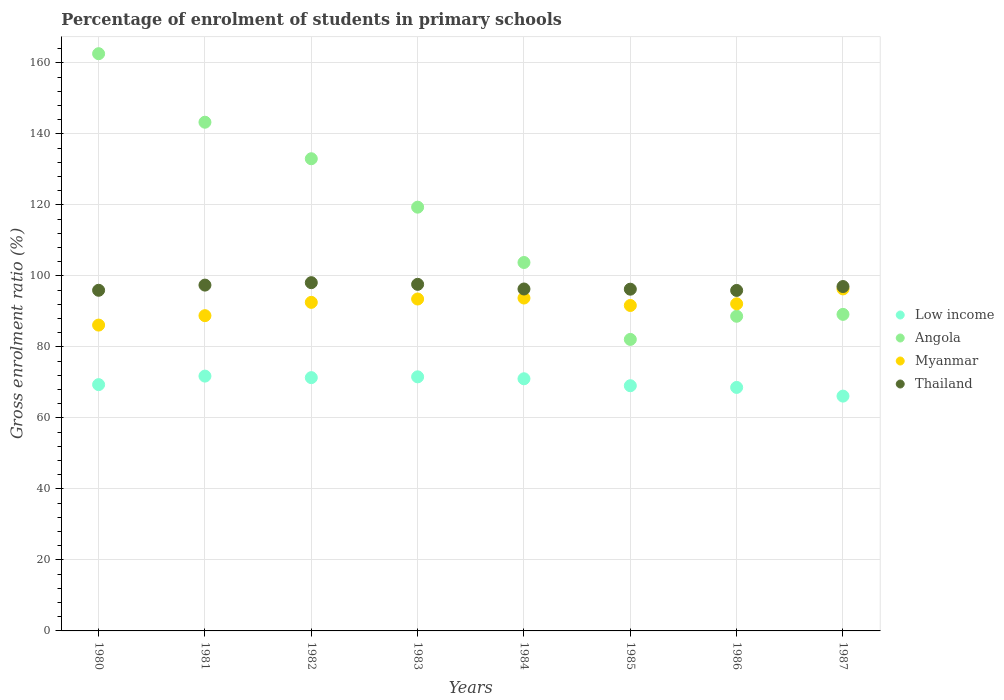What is the percentage of students enrolled in primary schools in Thailand in 1986?
Make the answer very short. 95.92. Across all years, what is the maximum percentage of students enrolled in primary schools in Angola?
Provide a short and direct response. 162.62. Across all years, what is the minimum percentage of students enrolled in primary schools in Myanmar?
Offer a terse response. 86.16. In which year was the percentage of students enrolled in primary schools in Angola maximum?
Your response must be concise. 1980. In which year was the percentage of students enrolled in primary schools in Myanmar minimum?
Give a very brief answer. 1980. What is the total percentage of students enrolled in primary schools in Thailand in the graph?
Offer a very short reply. 774.68. What is the difference between the percentage of students enrolled in primary schools in Angola in 1986 and that in 1987?
Provide a succinct answer. -0.53. What is the difference between the percentage of students enrolled in primary schools in Angola in 1984 and the percentage of students enrolled in primary schools in Low income in 1983?
Provide a short and direct response. 32.21. What is the average percentage of students enrolled in primary schools in Thailand per year?
Keep it short and to the point. 96.84. In the year 1984, what is the difference between the percentage of students enrolled in primary schools in Thailand and percentage of students enrolled in primary schools in Myanmar?
Make the answer very short. 2.54. What is the ratio of the percentage of students enrolled in primary schools in Myanmar in 1983 to that in 1984?
Offer a very short reply. 1. Is the percentage of students enrolled in primary schools in Low income in 1981 less than that in 1986?
Your answer should be very brief. No. What is the difference between the highest and the second highest percentage of students enrolled in primary schools in Angola?
Provide a short and direct response. 19.3. What is the difference between the highest and the lowest percentage of students enrolled in primary schools in Low income?
Ensure brevity in your answer.  5.64. Does the percentage of students enrolled in primary schools in Low income monotonically increase over the years?
Keep it short and to the point. No. Is the percentage of students enrolled in primary schools in Myanmar strictly greater than the percentage of students enrolled in primary schools in Angola over the years?
Provide a succinct answer. No. Is the percentage of students enrolled in primary schools in Thailand strictly less than the percentage of students enrolled in primary schools in Low income over the years?
Your response must be concise. No. How many years are there in the graph?
Offer a very short reply. 8. What is the difference between two consecutive major ticks on the Y-axis?
Offer a very short reply. 20. How are the legend labels stacked?
Make the answer very short. Vertical. What is the title of the graph?
Keep it short and to the point. Percentage of enrolment of students in primary schools. What is the Gross enrolment ratio (%) of Low income in 1980?
Provide a short and direct response. 69.39. What is the Gross enrolment ratio (%) in Angola in 1980?
Make the answer very short. 162.62. What is the Gross enrolment ratio (%) in Myanmar in 1980?
Offer a very short reply. 86.16. What is the Gross enrolment ratio (%) in Thailand in 1980?
Your answer should be very brief. 95.97. What is the Gross enrolment ratio (%) of Low income in 1981?
Your response must be concise. 71.79. What is the Gross enrolment ratio (%) in Angola in 1981?
Keep it short and to the point. 143.31. What is the Gross enrolment ratio (%) in Myanmar in 1981?
Keep it short and to the point. 88.82. What is the Gross enrolment ratio (%) of Thailand in 1981?
Make the answer very short. 97.42. What is the Gross enrolment ratio (%) in Low income in 1982?
Provide a succinct answer. 71.36. What is the Gross enrolment ratio (%) in Angola in 1982?
Make the answer very short. 133.02. What is the Gross enrolment ratio (%) in Myanmar in 1982?
Make the answer very short. 92.56. What is the Gross enrolment ratio (%) in Thailand in 1982?
Ensure brevity in your answer.  98.11. What is the Gross enrolment ratio (%) in Low income in 1983?
Your answer should be very brief. 71.58. What is the Gross enrolment ratio (%) of Angola in 1983?
Your answer should be very brief. 119.38. What is the Gross enrolment ratio (%) of Myanmar in 1983?
Your answer should be compact. 93.51. What is the Gross enrolment ratio (%) in Thailand in 1983?
Make the answer very short. 97.64. What is the Gross enrolment ratio (%) in Low income in 1984?
Provide a short and direct response. 71.04. What is the Gross enrolment ratio (%) in Angola in 1984?
Your answer should be compact. 103.79. What is the Gross enrolment ratio (%) of Myanmar in 1984?
Give a very brief answer. 93.79. What is the Gross enrolment ratio (%) of Thailand in 1984?
Ensure brevity in your answer.  96.33. What is the Gross enrolment ratio (%) in Low income in 1985?
Offer a terse response. 69.08. What is the Gross enrolment ratio (%) in Angola in 1985?
Provide a succinct answer. 82.12. What is the Gross enrolment ratio (%) of Myanmar in 1985?
Provide a short and direct response. 91.68. What is the Gross enrolment ratio (%) of Thailand in 1985?
Ensure brevity in your answer.  96.27. What is the Gross enrolment ratio (%) of Low income in 1986?
Your response must be concise. 68.6. What is the Gross enrolment ratio (%) in Angola in 1986?
Keep it short and to the point. 88.65. What is the Gross enrolment ratio (%) of Myanmar in 1986?
Make the answer very short. 92.15. What is the Gross enrolment ratio (%) of Thailand in 1986?
Ensure brevity in your answer.  95.92. What is the Gross enrolment ratio (%) of Low income in 1987?
Provide a short and direct response. 66.15. What is the Gross enrolment ratio (%) in Angola in 1987?
Your answer should be compact. 89.18. What is the Gross enrolment ratio (%) of Myanmar in 1987?
Your answer should be very brief. 96.35. What is the Gross enrolment ratio (%) of Thailand in 1987?
Your answer should be very brief. 97.02. Across all years, what is the maximum Gross enrolment ratio (%) in Low income?
Your answer should be very brief. 71.79. Across all years, what is the maximum Gross enrolment ratio (%) in Angola?
Ensure brevity in your answer.  162.62. Across all years, what is the maximum Gross enrolment ratio (%) of Myanmar?
Your answer should be compact. 96.35. Across all years, what is the maximum Gross enrolment ratio (%) in Thailand?
Keep it short and to the point. 98.11. Across all years, what is the minimum Gross enrolment ratio (%) in Low income?
Give a very brief answer. 66.15. Across all years, what is the minimum Gross enrolment ratio (%) of Angola?
Your answer should be compact. 82.12. Across all years, what is the minimum Gross enrolment ratio (%) in Myanmar?
Your answer should be compact. 86.16. Across all years, what is the minimum Gross enrolment ratio (%) of Thailand?
Ensure brevity in your answer.  95.92. What is the total Gross enrolment ratio (%) in Low income in the graph?
Offer a terse response. 558.97. What is the total Gross enrolment ratio (%) of Angola in the graph?
Make the answer very short. 922.07. What is the total Gross enrolment ratio (%) in Myanmar in the graph?
Your answer should be compact. 735.02. What is the total Gross enrolment ratio (%) of Thailand in the graph?
Your response must be concise. 774.68. What is the difference between the Gross enrolment ratio (%) in Low income in 1980 and that in 1981?
Keep it short and to the point. -2.4. What is the difference between the Gross enrolment ratio (%) in Angola in 1980 and that in 1981?
Make the answer very short. 19.3. What is the difference between the Gross enrolment ratio (%) of Myanmar in 1980 and that in 1981?
Provide a short and direct response. -2.66. What is the difference between the Gross enrolment ratio (%) of Thailand in 1980 and that in 1981?
Offer a terse response. -1.46. What is the difference between the Gross enrolment ratio (%) of Low income in 1980 and that in 1982?
Provide a succinct answer. -1.97. What is the difference between the Gross enrolment ratio (%) of Angola in 1980 and that in 1982?
Keep it short and to the point. 29.59. What is the difference between the Gross enrolment ratio (%) of Myanmar in 1980 and that in 1982?
Keep it short and to the point. -6.4. What is the difference between the Gross enrolment ratio (%) of Thailand in 1980 and that in 1982?
Ensure brevity in your answer.  -2.15. What is the difference between the Gross enrolment ratio (%) of Low income in 1980 and that in 1983?
Your answer should be compact. -2.2. What is the difference between the Gross enrolment ratio (%) in Angola in 1980 and that in 1983?
Offer a very short reply. 43.24. What is the difference between the Gross enrolment ratio (%) in Myanmar in 1980 and that in 1983?
Make the answer very short. -7.35. What is the difference between the Gross enrolment ratio (%) in Thailand in 1980 and that in 1983?
Offer a terse response. -1.67. What is the difference between the Gross enrolment ratio (%) of Low income in 1980 and that in 1984?
Your answer should be very brief. -1.65. What is the difference between the Gross enrolment ratio (%) of Angola in 1980 and that in 1984?
Ensure brevity in your answer.  58.82. What is the difference between the Gross enrolment ratio (%) of Myanmar in 1980 and that in 1984?
Keep it short and to the point. -7.63. What is the difference between the Gross enrolment ratio (%) of Thailand in 1980 and that in 1984?
Give a very brief answer. -0.36. What is the difference between the Gross enrolment ratio (%) in Low income in 1980 and that in 1985?
Make the answer very short. 0.31. What is the difference between the Gross enrolment ratio (%) of Angola in 1980 and that in 1985?
Provide a short and direct response. 80.49. What is the difference between the Gross enrolment ratio (%) in Myanmar in 1980 and that in 1985?
Make the answer very short. -5.52. What is the difference between the Gross enrolment ratio (%) in Thailand in 1980 and that in 1985?
Provide a succinct answer. -0.31. What is the difference between the Gross enrolment ratio (%) of Low income in 1980 and that in 1986?
Offer a very short reply. 0.79. What is the difference between the Gross enrolment ratio (%) of Angola in 1980 and that in 1986?
Your answer should be compact. 73.97. What is the difference between the Gross enrolment ratio (%) of Myanmar in 1980 and that in 1986?
Your response must be concise. -5.99. What is the difference between the Gross enrolment ratio (%) of Thailand in 1980 and that in 1986?
Your answer should be very brief. 0.04. What is the difference between the Gross enrolment ratio (%) of Low income in 1980 and that in 1987?
Offer a terse response. 3.23. What is the difference between the Gross enrolment ratio (%) in Angola in 1980 and that in 1987?
Ensure brevity in your answer.  73.44. What is the difference between the Gross enrolment ratio (%) of Myanmar in 1980 and that in 1987?
Keep it short and to the point. -10.19. What is the difference between the Gross enrolment ratio (%) of Thailand in 1980 and that in 1987?
Keep it short and to the point. -1.05. What is the difference between the Gross enrolment ratio (%) in Low income in 1981 and that in 1982?
Your answer should be very brief. 0.43. What is the difference between the Gross enrolment ratio (%) of Angola in 1981 and that in 1982?
Offer a terse response. 10.29. What is the difference between the Gross enrolment ratio (%) in Myanmar in 1981 and that in 1982?
Offer a very short reply. -3.74. What is the difference between the Gross enrolment ratio (%) in Thailand in 1981 and that in 1982?
Make the answer very short. -0.69. What is the difference between the Gross enrolment ratio (%) in Low income in 1981 and that in 1983?
Your answer should be very brief. 0.21. What is the difference between the Gross enrolment ratio (%) of Angola in 1981 and that in 1983?
Keep it short and to the point. 23.93. What is the difference between the Gross enrolment ratio (%) in Myanmar in 1981 and that in 1983?
Ensure brevity in your answer.  -4.69. What is the difference between the Gross enrolment ratio (%) of Thailand in 1981 and that in 1983?
Provide a succinct answer. -0.22. What is the difference between the Gross enrolment ratio (%) of Low income in 1981 and that in 1984?
Offer a very short reply. 0.75. What is the difference between the Gross enrolment ratio (%) in Angola in 1981 and that in 1984?
Provide a succinct answer. 39.52. What is the difference between the Gross enrolment ratio (%) of Myanmar in 1981 and that in 1984?
Keep it short and to the point. -4.97. What is the difference between the Gross enrolment ratio (%) of Thailand in 1981 and that in 1984?
Keep it short and to the point. 1.1. What is the difference between the Gross enrolment ratio (%) of Low income in 1981 and that in 1985?
Your response must be concise. 2.71. What is the difference between the Gross enrolment ratio (%) of Angola in 1981 and that in 1985?
Your answer should be very brief. 61.19. What is the difference between the Gross enrolment ratio (%) in Myanmar in 1981 and that in 1985?
Provide a short and direct response. -2.87. What is the difference between the Gross enrolment ratio (%) of Thailand in 1981 and that in 1985?
Offer a very short reply. 1.15. What is the difference between the Gross enrolment ratio (%) of Low income in 1981 and that in 1986?
Offer a very short reply. 3.19. What is the difference between the Gross enrolment ratio (%) in Angola in 1981 and that in 1986?
Provide a succinct answer. 54.67. What is the difference between the Gross enrolment ratio (%) of Myanmar in 1981 and that in 1986?
Keep it short and to the point. -3.33. What is the difference between the Gross enrolment ratio (%) in Thailand in 1981 and that in 1986?
Give a very brief answer. 1.5. What is the difference between the Gross enrolment ratio (%) of Low income in 1981 and that in 1987?
Make the answer very short. 5.64. What is the difference between the Gross enrolment ratio (%) in Angola in 1981 and that in 1987?
Your answer should be compact. 54.14. What is the difference between the Gross enrolment ratio (%) of Myanmar in 1981 and that in 1987?
Offer a very short reply. -7.54. What is the difference between the Gross enrolment ratio (%) in Thailand in 1981 and that in 1987?
Your answer should be compact. 0.4. What is the difference between the Gross enrolment ratio (%) in Low income in 1982 and that in 1983?
Your response must be concise. -0.22. What is the difference between the Gross enrolment ratio (%) of Angola in 1982 and that in 1983?
Make the answer very short. 13.64. What is the difference between the Gross enrolment ratio (%) of Myanmar in 1982 and that in 1983?
Keep it short and to the point. -0.94. What is the difference between the Gross enrolment ratio (%) of Thailand in 1982 and that in 1983?
Offer a terse response. 0.47. What is the difference between the Gross enrolment ratio (%) in Low income in 1982 and that in 1984?
Make the answer very short. 0.32. What is the difference between the Gross enrolment ratio (%) of Angola in 1982 and that in 1984?
Give a very brief answer. 29.23. What is the difference between the Gross enrolment ratio (%) of Myanmar in 1982 and that in 1984?
Offer a terse response. -1.22. What is the difference between the Gross enrolment ratio (%) in Thailand in 1982 and that in 1984?
Make the answer very short. 1.78. What is the difference between the Gross enrolment ratio (%) in Low income in 1982 and that in 1985?
Your response must be concise. 2.28. What is the difference between the Gross enrolment ratio (%) of Angola in 1982 and that in 1985?
Ensure brevity in your answer.  50.9. What is the difference between the Gross enrolment ratio (%) of Myanmar in 1982 and that in 1985?
Offer a very short reply. 0.88. What is the difference between the Gross enrolment ratio (%) in Thailand in 1982 and that in 1985?
Offer a very short reply. 1.84. What is the difference between the Gross enrolment ratio (%) in Low income in 1982 and that in 1986?
Ensure brevity in your answer.  2.76. What is the difference between the Gross enrolment ratio (%) in Angola in 1982 and that in 1986?
Give a very brief answer. 44.38. What is the difference between the Gross enrolment ratio (%) of Myanmar in 1982 and that in 1986?
Give a very brief answer. 0.41. What is the difference between the Gross enrolment ratio (%) of Thailand in 1982 and that in 1986?
Make the answer very short. 2.19. What is the difference between the Gross enrolment ratio (%) of Low income in 1982 and that in 1987?
Make the answer very short. 5.21. What is the difference between the Gross enrolment ratio (%) of Angola in 1982 and that in 1987?
Offer a terse response. 43.85. What is the difference between the Gross enrolment ratio (%) in Myanmar in 1982 and that in 1987?
Make the answer very short. -3.79. What is the difference between the Gross enrolment ratio (%) in Thailand in 1982 and that in 1987?
Offer a very short reply. 1.09. What is the difference between the Gross enrolment ratio (%) of Low income in 1983 and that in 1984?
Provide a short and direct response. 0.54. What is the difference between the Gross enrolment ratio (%) of Angola in 1983 and that in 1984?
Provide a succinct answer. 15.59. What is the difference between the Gross enrolment ratio (%) of Myanmar in 1983 and that in 1984?
Give a very brief answer. -0.28. What is the difference between the Gross enrolment ratio (%) in Thailand in 1983 and that in 1984?
Your answer should be compact. 1.31. What is the difference between the Gross enrolment ratio (%) of Low income in 1983 and that in 1985?
Make the answer very short. 2.5. What is the difference between the Gross enrolment ratio (%) in Angola in 1983 and that in 1985?
Your answer should be compact. 37.26. What is the difference between the Gross enrolment ratio (%) of Myanmar in 1983 and that in 1985?
Your response must be concise. 1.82. What is the difference between the Gross enrolment ratio (%) in Thailand in 1983 and that in 1985?
Your response must be concise. 1.37. What is the difference between the Gross enrolment ratio (%) of Low income in 1983 and that in 1986?
Make the answer very short. 2.98. What is the difference between the Gross enrolment ratio (%) of Angola in 1983 and that in 1986?
Make the answer very short. 30.73. What is the difference between the Gross enrolment ratio (%) in Myanmar in 1983 and that in 1986?
Your answer should be compact. 1.35. What is the difference between the Gross enrolment ratio (%) in Thailand in 1983 and that in 1986?
Your response must be concise. 1.72. What is the difference between the Gross enrolment ratio (%) of Low income in 1983 and that in 1987?
Your answer should be compact. 5.43. What is the difference between the Gross enrolment ratio (%) of Angola in 1983 and that in 1987?
Give a very brief answer. 30.2. What is the difference between the Gross enrolment ratio (%) in Myanmar in 1983 and that in 1987?
Your response must be concise. -2.85. What is the difference between the Gross enrolment ratio (%) in Thailand in 1983 and that in 1987?
Your answer should be compact. 0.62. What is the difference between the Gross enrolment ratio (%) in Low income in 1984 and that in 1985?
Give a very brief answer. 1.96. What is the difference between the Gross enrolment ratio (%) in Angola in 1984 and that in 1985?
Your response must be concise. 21.67. What is the difference between the Gross enrolment ratio (%) in Myanmar in 1984 and that in 1985?
Offer a very short reply. 2.1. What is the difference between the Gross enrolment ratio (%) in Thailand in 1984 and that in 1985?
Make the answer very short. 0.05. What is the difference between the Gross enrolment ratio (%) in Low income in 1984 and that in 1986?
Offer a terse response. 2.44. What is the difference between the Gross enrolment ratio (%) in Angola in 1984 and that in 1986?
Make the answer very short. 15.15. What is the difference between the Gross enrolment ratio (%) in Myanmar in 1984 and that in 1986?
Give a very brief answer. 1.63. What is the difference between the Gross enrolment ratio (%) in Thailand in 1984 and that in 1986?
Provide a short and direct response. 0.41. What is the difference between the Gross enrolment ratio (%) in Low income in 1984 and that in 1987?
Offer a terse response. 4.89. What is the difference between the Gross enrolment ratio (%) in Angola in 1984 and that in 1987?
Keep it short and to the point. 14.62. What is the difference between the Gross enrolment ratio (%) in Myanmar in 1984 and that in 1987?
Ensure brevity in your answer.  -2.57. What is the difference between the Gross enrolment ratio (%) in Thailand in 1984 and that in 1987?
Your answer should be very brief. -0.69. What is the difference between the Gross enrolment ratio (%) of Low income in 1985 and that in 1986?
Give a very brief answer. 0.48. What is the difference between the Gross enrolment ratio (%) in Angola in 1985 and that in 1986?
Provide a short and direct response. -6.52. What is the difference between the Gross enrolment ratio (%) of Myanmar in 1985 and that in 1986?
Make the answer very short. -0.47. What is the difference between the Gross enrolment ratio (%) of Thailand in 1985 and that in 1986?
Your response must be concise. 0.35. What is the difference between the Gross enrolment ratio (%) in Low income in 1985 and that in 1987?
Your response must be concise. 2.93. What is the difference between the Gross enrolment ratio (%) of Angola in 1985 and that in 1987?
Your response must be concise. -7.05. What is the difference between the Gross enrolment ratio (%) of Myanmar in 1985 and that in 1987?
Offer a very short reply. -4.67. What is the difference between the Gross enrolment ratio (%) of Thailand in 1985 and that in 1987?
Your response must be concise. -0.75. What is the difference between the Gross enrolment ratio (%) in Low income in 1986 and that in 1987?
Offer a very short reply. 2.45. What is the difference between the Gross enrolment ratio (%) of Angola in 1986 and that in 1987?
Offer a very short reply. -0.53. What is the difference between the Gross enrolment ratio (%) in Myanmar in 1986 and that in 1987?
Provide a succinct answer. -4.2. What is the difference between the Gross enrolment ratio (%) of Thailand in 1986 and that in 1987?
Your answer should be compact. -1.1. What is the difference between the Gross enrolment ratio (%) of Low income in 1980 and the Gross enrolment ratio (%) of Angola in 1981?
Your response must be concise. -73.93. What is the difference between the Gross enrolment ratio (%) in Low income in 1980 and the Gross enrolment ratio (%) in Myanmar in 1981?
Your answer should be compact. -19.43. What is the difference between the Gross enrolment ratio (%) of Low income in 1980 and the Gross enrolment ratio (%) of Thailand in 1981?
Ensure brevity in your answer.  -28.04. What is the difference between the Gross enrolment ratio (%) in Angola in 1980 and the Gross enrolment ratio (%) in Myanmar in 1981?
Offer a very short reply. 73.8. What is the difference between the Gross enrolment ratio (%) in Angola in 1980 and the Gross enrolment ratio (%) in Thailand in 1981?
Keep it short and to the point. 65.19. What is the difference between the Gross enrolment ratio (%) of Myanmar in 1980 and the Gross enrolment ratio (%) of Thailand in 1981?
Your answer should be compact. -11.26. What is the difference between the Gross enrolment ratio (%) of Low income in 1980 and the Gross enrolment ratio (%) of Angola in 1982?
Make the answer very short. -63.64. What is the difference between the Gross enrolment ratio (%) in Low income in 1980 and the Gross enrolment ratio (%) in Myanmar in 1982?
Your response must be concise. -23.18. What is the difference between the Gross enrolment ratio (%) of Low income in 1980 and the Gross enrolment ratio (%) of Thailand in 1982?
Provide a succinct answer. -28.73. What is the difference between the Gross enrolment ratio (%) of Angola in 1980 and the Gross enrolment ratio (%) of Myanmar in 1982?
Make the answer very short. 70.06. What is the difference between the Gross enrolment ratio (%) in Angola in 1980 and the Gross enrolment ratio (%) in Thailand in 1982?
Provide a short and direct response. 64.5. What is the difference between the Gross enrolment ratio (%) of Myanmar in 1980 and the Gross enrolment ratio (%) of Thailand in 1982?
Your answer should be very brief. -11.95. What is the difference between the Gross enrolment ratio (%) in Low income in 1980 and the Gross enrolment ratio (%) in Angola in 1983?
Offer a terse response. -49.99. What is the difference between the Gross enrolment ratio (%) of Low income in 1980 and the Gross enrolment ratio (%) of Myanmar in 1983?
Ensure brevity in your answer.  -24.12. What is the difference between the Gross enrolment ratio (%) of Low income in 1980 and the Gross enrolment ratio (%) of Thailand in 1983?
Keep it short and to the point. -28.25. What is the difference between the Gross enrolment ratio (%) of Angola in 1980 and the Gross enrolment ratio (%) of Myanmar in 1983?
Provide a succinct answer. 69.11. What is the difference between the Gross enrolment ratio (%) in Angola in 1980 and the Gross enrolment ratio (%) in Thailand in 1983?
Your response must be concise. 64.98. What is the difference between the Gross enrolment ratio (%) of Myanmar in 1980 and the Gross enrolment ratio (%) of Thailand in 1983?
Offer a terse response. -11.48. What is the difference between the Gross enrolment ratio (%) of Low income in 1980 and the Gross enrolment ratio (%) of Angola in 1984?
Offer a very short reply. -34.41. What is the difference between the Gross enrolment ratio (%) in Low income in 1980 and the Gross enrolment ratio (%) in Myanmar in 1984?
Keep it short and to the point. -24.4. What is the difference between the Gross enrolment ratio (%) in Low income in 1980 and the Gross enrolment ratio (%) in Thailand in 1984?
Provide a short and direct response. -26.94. What is the difference between the Gross enrolment ratio (%) in Angola in 1980 and the Gross enrolment ratio (%) in Myanmar in 1984?
Your answer should be very brief. 68.83. What is the difference between the Gross enrolment ratio (%) of Angola in 1980 and the Gross enrolment ratio (%) of Thailand in 1984?
Your answer should be compact. 66.29. What is the difference between the Gross enrolment ratio (%) in Myanmar in 1980 and the Gross enrolment ratio (%) in Thailand in 1984?
Ensure brevity in your answer.  -10.17. What is the difference between the Gross enrolment ratio (%) in Low income in 1980 and the Gross enrolment ratio (%) in Angola in 1985?
Your response must be concise. -12.74. What is the difference between the Gross enrolment ratio (%) in Low income in 1980 and the Gross enrolment ratio (%) in Myanmar in 1985?
Keep it short and to the point. -22.3. What is the difference between the Gross enrolment ratio (%) of Low income in 1980 and the Gross enrolment ratio (%) of Thailand in 1985?
Your answer should be very brief. -26.89. What is the difference between the Gross enrolment ratio (%) of Angola in 1980 and the Gross enrolment ratio (%) of Myanmar in 1985?
Provide a succinct answer. 70.93. What is the difference between the Gross enrolment ratio (%) in Angola in 1980 and the Gross enrolment ratio (%) in Thailand in 1985?
Ensure brevity in your answer.  66.34. What is the difference between the Gross enrolment ratio (%) in Myanmar in 1980 and the Gross enrolment ratio (%) in Thailand in 1985?
Provide a succinct answer. -10.11. What is the difference between the Gross enrolment ratio (%) in Low income in 1980 and the Gross enrolment ratio (%) in Angola in 1986?
Your answer should be very brief. -19.26. What is the difference between the Gross enrolment ratio (%) in Low income in 1980 and the Gross enrolment ratio (%) in Myanmar in 1986?
Ensure brevity in your answer.  -22.77. What is the difference between the Gross enrolment ratio (%) in Low income in 1980 and the Gross enrolment ratio (%) in Thailand in 1986?
Your answer should be very brief. -26.54. What is the difference between the Gross enrolment ratio (%) of Angola in 1980 and the Gross enrolment ratio (%) of Myanmar in 1986?
Provide a succinct answer. 70.47. What is the difference between the Gross enrolment ratio (%) in Angola in 1980 and the Gross enrolment ratio (%) in Thailand in 1986?
Your answer should be very brief. 66.7. What is the difference between the Gross enrolment ratio (%) in Myanmar in 1980 and the Gross enrolment ratio (%) in Thailand in 1986?
Give a very brief answer. -9.76. What is the difference between the Gross enrolment ratio (%) of Low income in 1980 and the Gross enrolment ratio (%) of Angola in 1987?
Keep it short and to the point. -19.79. What is the difference between the Gross enrolment ratio (%) of Low income in 1980 and the Gross enrolment ratio (%) of Myanmar in 1987?
Your answer should be very brief. -26.97. What is the difference between the Gross enrolment ratio (%) in Low income in 1980 and the Gross enrolment ratio (%) in Thailand in 1987?
Give a very brief answer. -27.63. What is the difference between the Gross enrolment ratio (%) in Angola in 1980 and the Gross enrolment ratio (%) in Myanmar in 1987?
Keep it short and to the point. 66.26. What is the difference between the Gross enrolment ratio (%) of Angola in 1980 and the Gross enrolment ratio (%) of Thailand in 1987?
Your response must be concise. 65.6. What is the difference between the Gross enrolment ratio (%) in Myanmar in 1980 and the Gross enrolment ratio (%) in Thailand in 1987?
Your answer should be very brief. -10.86. What is the difference between the Gross enrolment ratio (%) in Low income in 1981 and the Gross enrolment ratio (%) in Angola in 1982?
Give a very brief answer. -61.24. What is the difference between the Gross enrolment ratio (%) of Low income in 1981 and the Gross enrolment ratio (%) of Myanmar in 1982?
Give a very brief answer. -20.77. What is the difference between the Gross enrolment ratio (%) of Low income in 1981 and the Gross enrolment ratio (%) of Thailand in 1982?
Your answer should be very brief. -26.32. What is the difference between the Gross enrolment ratio (%) of Angola in 1981 and the Gross enrolment ratio (%) of Myanmar in 1982?
Provide a short and direct response. 50.75. What is the difference between the Gross enrolment ratio (%) in Angola in 1981 and the Gross enrolment ratio (%) in Thailand in 1982?
Offer a terse response. 45.2. What is the difference between the Gross enrolment ratio (%) of Myanmar in 1981 and the Gross enrolment ratio (%) of Thailand in 1982?
Your response must be concise. -9.3. What is the difference between the Gross enrolment ratio (%) of Low income in 1981 and the Gross enrolment ratio (%) of Angola in 1983?
Offer a very short reply. -47.59. What is the difference between the Gross enrolment ratio (%) of Low income in 1981 and the Gross enrolment ratio (%) of Myanmar in 1983?
Ensure brevity in your answer.  -21.72. What is the difference between the Gross enrolment ratio (%) in Low income in 1981 and the Gross enrolment ratio (%) in Thailand in 1983?
Provide a short and direct response. -25.85. What is the difference between the Gross enrolment ratio (%) of Angola in 1981 and the Gross enrolment ratio (%) of Myanmar in 1983?
Your response must be concise. 49.81. What is the difference between the Gross enrolment ratio (%) of Angola in 1981 and the Gross enrolment ratio (%) of Thailand in 1983?
Provide a succinct answer. 45.67. What is the difference between the Gross enrolment ratio (%) in Myanmar in 1981 and the Gross enrolment ratio (%) in Thailand in 1983?
Provide a short and direct response. -8.82. What is the difference between the Gross enrolment ratio (%) of Low income in 1981 and the Gross enrolment ratio (%) of Angola in 1984?
Give a very brief answer. -32.01. What is the difference between the Gross enrolment ratio (%) of Low income in 1981 and the Gross enrolment ratio (%) of Myanmar in 1984?
Provide a short and direct response. -22. What is the difference between the Gross enrolment ratio (%) in Low income in 1981 and the Gross enrolment ratio (%) in Thailand in 1984?
Keep it short and to the point. -24.54. What is the difference between the Gross enrolment ratio (%) of Angola in 1981 and the Gross enrolment ratio (%) of Myanmar in 1984?
Offer a very short reply. 49.53. What is the difference between the Gross enrolment ratio (%) of Angola in 1981 and the Gross enrolment ratio (%) of Thailand in 1984?
Your response must be concise. 46.99. What is the difference between the Gross enrolment ratio (%) in Myanmar in 1981 and the Gross enrolment ratio (%) in Thailand in 1984?
Your answer should be very brief. -7.51. What is the difference between the Gross enrolment ratio (%) in Low income in 1981 and the Gross enrolment ratio (%) in Angola in 1985?
Provide a short and direct response. -10.34. What is the difference between the Gross enrolment ratio (%) in Low income in 1981 and the Gross enrolment ratio (%) in Myanmar in 1985?
Provide a short and direct response. -19.9. What is the difference between the Gross enrolment ratio (%) of Low income in 1981 and the Gross enrolment ratio (%) of Thailand in 1985?
Ensure brevity in your answer.  -24.49. What is the difference between the Gross enrolment ratio (%) of Angola in 1981 and the Gross enrolment ratio (%) of Myanmar in 1985?
Offer a terse response. 51.63. What is the difference between the Gross enrolment ratio (%) of Angola in 1981 and the Gross enrolment ratio (%) of Thailand in 1985?
Your answer should be very brief. 47.04. What is the difference between the Gross enrolment ratio (%) in Myanmar in 1981 and the Gross enrolment ratio (%) in Thailand in 1985?
Make the answer very short. -7.46. What is the difference between the Gross enrolment ratio (%) of Low income in 1981 and the Gross enrolment ratio (%) of Angola in 1986?
Offer a terse response. -16.86. What is the difference between the Gross enrolment ratio (%) of Low income in 1981 and the Gross enrolment ratio (%) of Myanmar in 1986?
Your response must be concise. -20.36. What is the difference between the Gross enrolment ratio (%) in Low income in 1981 and the Gross enrolment ratio (%) in Thailand in 1986?
Offer a very short reply. -24.13. What is the difference between the Gross enrolment ratio (%) of Angola in 1981 and the Gross enrolment ratio (%) of Myanmar in 1986?
Your answer should be very brief. 51.16. What is the difference between the Gross enrolment ratio (%) of Angola in 1981 and the Gross enrolment ratio (%) of Thailand in 1986?
Keep it short and to the point. 47.39. What is the difference between the Gross enrolment ratio (%) of Myanmar in 1981 and the Gross enrolment ratio (%) of Thailand in 1986?
Ensure brevity in your answer.  -7.1. What is the difference between the Gross enrolment ratio (%) in Low income in 1981 and the Gross enrolment ratio (%) in Angola in 1987?
Your answer should be compact. -17.39. What is the difference between the Gross enrolment ratio (%) in Low income in 1981 and the Gross enrolment ratio (%) in Myanmar in 1987?
Provide a succinct answer. -24.56. What is the difference between the Gross enrolment ratio (%) of Low income in 1981 and the Gross enrolment ratio (%) of Thailand in 1987?
Ensure brevity in your answer.  -25.23. What is the difference between the Gross enrolment ratio (%) of Angola in 1981 and the Gross enrolment ratio (%) of Myanmar in 1987?
Your response must be concise. 46.96. What is the difference between the Gross enrolment ratio (%) of Angola in 1981 and the Gross enrolment ratio (%) of Thailand in 1987?
Offer a very short reply. 46.29. What is the difference between the Gross enrolment ratio (%) in Myanmar in 1981 and the Gross enrolment ratio (%) in Thailand in 1987?
Provide a succinct answer. -8.2. What is the difference between the Gross enrolment ratio (%) of Low income in 1982 and the Gross enrolment ratio (%) of Angola in 1983?
Your answer should be very brief. -48.02. What is the difference between the Gross enrolment ratio (%) in Low income in 1982 and the Gross enrolment ratio (%) in Myanmar in 1983?
Your answer should be compact. -22.15. What is the difference between the Gross enrolment ratio (%) in Low income in 1982 and the Gross enrolment ratio (%) in Thailand in 1983?
Offer a very short reply. -26.28. What is the difference between the Gross enrolment ratio (%) of Angola in 1982 and the Gross enrolment ratio (%) of Myanmar in 1983?
Your answer should be compact. 39.52. What is the difference between the Gross enrolment ratio (%) of Angola in 1982 and the Gross enrolment ratio (%) of Thailand in 1983?
Your response must be concise. 35.38. What is the difference between the Gross enrolment ratio (%) in Myanmar in 1982 and the Gross enrolment ratio (%) in Thailand in 1983?
Your answer should be compact. -5.08. What is the difference between the Gross enrolment ratio (%) of Low income in 1982 and the Gross enrolment ratio (%) of Angola in 1984?
Give a very brief answer. -32.44. What is the difference between the Gross enrolment ratio (%) in Low income in 1982 and the Gross enrolment ratio (%) in Myanmar in 1984?
Ensure brevity in your answer.  -22.43. What is the difference between the Gross enrolment ratio (%) in Low income in 1982 and the Gross enrolment ratio (%) in Thailand in 1984?
Provide a short and direct response. -24.97. What is the difference between the Gross enrolment ratio (%) in Angola in 1982 and the Gross enrolment ratio (%) in Myanmar in 1984?
Your response must be concise. 39.24. What is the difference between the Gross enrolment ratio (%) in Angola in 1982 and the Gross enrolment ratio (%) in Thailand in 1984?
Provide a short and direct response. 36.7. What is the difference between the Gross enrolment ratio (%) in Myanmar in 1982 and the Gross enrolment ratio (%) in Thailand in 1984?
Provide a succinct answer. -3.77. What is the difference between the Gross enrolment ratio (%) in Low income in 1982 and the Gross enrolment ratio (%) in Angola in 1985?
Offer a terse response. -10.77. What is the difference between the Gross enrolment ratio (%) in Low income in 1982 and the Gross enrolment ratio (%) in Myanmar in 1985?
Your answer should be very brief. -20.33. What is the difference between the Gross enrolment ratio (%) of Low income in 1982 and the Gross enrolment ratio (%) of Thailand in 1985?
Offer a terse response. -24.92. What is the difference between the Gross enrolment ratio (%) in Angola in 1982 and the Gross enrolment ratio (%) in Myanmar in 1985?
Your answer should be compact. 41.34. What is the difference between the Gross enrolment ratio (%) of Angola in 1982 and the Gross enrolment ratio (%) of Thailand in 1985?
Give a very brief answer. 36.75. What is the difference between the Gross enrolment ratio (%) in Myanmar in 1982 and the Gross enrolment ratio (%) in Thailand in 1985?
Offer a terse response. -3.71. What is the difference between the Gross enrolment ratio (%) of Low income in 1982 and the Gross enrolment ratio (%) of Angola in 1986?
Make the answer very short. -17.29. What is the difference between the Gross enrolment ratio (%) in Low income in 1982 and the Gross enrolment ratio (%) in Myanmar in 1986?
Your response must be concise. -20.8. What is the difference between the Gross enrolment ratio (%) of Low income in 1982 and the Gross enrolment ratio (%) of Thailand in 1986?
Offer a very short reply. -24.57. What is the difference between the Gross enrolment ratio (%) of Angola in 1982 and the Gross enrolment ratio (%) of Myanmar in 1986?
Provide a short and direct response. 40.87. What is the difference between the Gross enrolment ratio (%) in Angola in 1982 and the Gross enrolment ratio (%) in Thailand in 1986?
Your answer should be compact. 37.1. What is the difference between the Gross enrolment ratio (%) of Myanmar in 1982 and the Gross enrolment ratio (%) of Thailand in 1986?
Provide a short and direct response. -3.36. What is the difference between the Gross enrolment ratio (%) of Low income in 1982 and the Gross enrolment ratio (%) of Angola in 1987?
Offer a terse response. -17.82. What is the difference between the Gross enrolment ratio (%) of Low income in 1982 and the Gross enrolment ratio (%) of Myanmar in 1987?
Your response must be concise. -25. What is the difference between the Gross enrolment ratio (%) in Low income in 1982 and the Gross enrolment ratio (%) in Thailand in 1987?
Provide a short and direct response. -25.66. What is the difference between the Gross enrolment ratio (%) of Angola in 1982 and the Gross enrolment ratio (%) of Myanmar in 1987?
Ensure brevity in your answer.  36.67. What is the difference between the Gross enrolment ratio (%) of Angola in 1982 and the Gross enrolment ratio (%) of Thailand in 1987?
Ensure brevity in your answer.  36. What is the difference between the Gross enrolment ratio (%) in Myanmar in 1982 and the Gross enrolment ratio (%) in Thailand in 1987?
Your answer should be compact. -4.46. What is the difference between the Gross enrolment ratio (%) in Low income in 1983 and the Gross enrolment ratio (%) in Angola in 1984?
Offer a very short reply. -32.21. What is the difference between the Gross enrolment ratio (%) in Low income in 1983 and the Gross enrolment ratio (%) in Myanmar in 1984?
Make the answer very short. -22.21. What is the difference between the Gross enrolment ratio (%) of Low income in 1983 and the Gross enrolment ratio (%) of Thailand in 1984?
Provide a short and direct response. -24.75. What is the difference between the Gross enrolment ratio (%) of Angola in 1983 and the Gross enrolment ratio (%) of Myanmar in 1984?
Offer a terse response. 25.59. What is the difference between the Gross enrolment ratio (%) of Angola in 1983 and the Gross enrolment ratio (%) of Thailand in 1984?
Offer a very short reply. 23.05. What is the difference between the Gross enrolment ratio (%) in Myanmar in 1983 and the Gross enrolment ratio (%) in Thailand in 1984?
Your response must be concise. -2.82. What is the difference between the Gross enrolment ratio (%) in Low income in 1983 and the Gross enrolment ratio (%) in Angola in 1985?
Provide a succinct answer. -10.54. What is the difference between the Gross enrolment ratio (%) of Low income in 1983 and the Gross enrolment ratio (%) of Myanmar in 1985?
Keep it short and to the point. -20.1. What is the difference between the Gross enrolment ratio (%) in Low income in 1983 and the Gross enrolment ratio (%) in Thailand in 1985?
Your answer should be compact. -24.69. What is the difference between the Gross enrolment ratio (%) in Angola in 1983 and the Gross enrolment ratio (%) in Myanmar in 1985?
Offer a very short reply. 27.7. What is the difference between the Gross enrolment ratio (%) in Angola in 1983 and the Gross enrolment ratio (%) in Thailand in 1985?
Provide a succinct answer. 23.11. What is the difference between the Gross enrolment ratio (%) of Myanmar in 1983 and the Gross enrolment ratio (%) of Thailand in 1985?
Offer a very short reply. -2.77. What is the difference between the Gross enrolment ratio (%) of Low income in 1983 and the Gross enrolment ratio (%) of Angola in 1986?
Offer a terse response. -17.07. What is the difference between the Gross enrolment ratio (%) in Low income in 1983 and the Gross enrolment ratio (%) in Myanmar in 1986?
Provide a short and direct response. -20.57. What is the difference between the Gross enrolment ratio (%) in Low income in 1983 and the Gross enrolment ratio (%) in Thailand in 1986?
Offer a terse response. -24.34. What is the difference between the Gross enrolment ratio (%) of Angola in 1983 and the Gross enrolment ratio (%) of Myanmar in 1986?
Offer a very short reply. 27.23. What is the difference between the Gross enrolment ratio (%) in Angola in 1983 and the Gross enrolment ratio (%) in Thailand in 1986?
Your answer should be very brief. 23.46. What is the difference between the Gross enrolment ratio (%) of Myanmar in 1983 and the Gross enrolment ratio (%) of Thailand in 1986?
Provide a short and direct response. -2.42. What is the difference between the Gross enrolment ratio (%) of Low income in 1983 and the Gross enrolment ratio (%) of Angola in 1987?
Your answer should be very brief. -17.6. What is the difference between the Gross enrolment ratio (%) in Low income in 1983 and the Gross enrolment ratio (%) in Myanmar in 1987?
Make the answer very short. -24.77. What is the difference between the Gross enrolment ratio (%) in Low income in 1983 and the Gross enrolment ratio (%) in Thailand in 1987?
Provide a short and direct response. -25.44. What is the difference between the Gross enrolment ratio (%) of Angola in 1983 and the Gross enrolment ratio (%) of Myanmar in 1987?
Offer a very short reply. 23.03. What is the difference between the Gross enrolment ratio (%) in Angola in 1983 and the Gross enrolment ratio (%) in Thailand in 1987?
Your answer should be very brief. 22.36. What is the difference between the Gross enrolment ratio (%) in Myanmar in 1983 and the Gross enrolment ratio (%) in Thailand in 1987?
Provide a short and direct response. -3.51. What is the difference between the Gross enrolment ratio (%) in Low income in 1984 and the Gross enrolment ratio (%) in Angola in 1985?
Your response must be concise. -11.09. What is the difference between the Gross enrolment ratio (%) in Low income in 1984 and the Gross enrolment ratio (%) in Myanmar in 1985?
Offer a very short reply. -20.65. What is the difference between the Gross enrolment ratio (%) of Low income in 1984 and the Gross enrolment ratio (%) of Thailand in 1985?
Provide a short and direct response. -25.24. What is the difference between the Gross enrolment ratio (%) of Angola in 1984 and the Gross enrolment ratio (%) of Myanmar in 1985?
Make the answer very short. 12.11. What is the difference between the Gross enrolment ratio (%) in Angola in 1984 and the Gross enrolment ratio (%) in Thailand in 1985?
Your answer should be compact. 7.52. What is the difference between the Gross enrolment ratio (%) in Myanmar in 1984 and the Gross enrolment ratio (%) in Thailand in 1985?
Make the answer very short. -2.49. What is the difference between the Gross enrolment ratio (%) in Low income in 1984 and the Gross enrolment ratio (%) in Angola in 1986?
Keep it short and to the point. -17.61. What is the difference between the Gross enrolment ratio (%) of Low income in 1984 and the Gross enrolment ratio (%) of Myanmar in 1986?
Give a very brief answer. -21.12. What is the difference between the Gross enrolment ratio (%) of Low income in 1984 and the Gross enrolment ratio (%) of Thailand in 1986?
Offer a terse response. -24.89. What is the difference between the Gross enrolment ratio (%) of Angola in 1984 and the Gross enrolment ratio (%) of Myanmar in 1986?
Keep it short and to the point. 11.64. What is the difference between the Gross enrolment ratio (%) in Angola in 1984 and the Gross enrolment ratio (%) in Thailand in 1986?
Give a very brief answer. 7.87. What is the difference between the Gross enrolment ratio (%) of Myanmar in 1984 and the Gross enrolment ratio (%) of Thailand in 1986?
Make the answer very short. -2.14. What is the difference between the Gross enrolment ratio (%) of Low income in 1984 and the Gross enrolment ratio (%) of Angola in 1987?
Offer a terse response. -18.14. What is the difference between the Gross enrolment ratio (%) in Low income in 1984 and the Gross enrolment ratio (%) in Myanmar in 1987?
Make the answer very short. -25.32. What is the difference between the Gross enrolment ratio (%) in Low income in 1984 and the Gross enrolment ratio (%) in Thailand in 1987?
Your answer should be very brief. -25.98. What is the difference between the Gross enrolment ratio (%) in Angola in 1984 and the Gross enrolment ratio (%) in Myanmar in 1987?
Provide a succinct answer. 7.44. What is the difference between the Gross enrolment ratio (%) of Angola in 1984 and the Gross enrolment ratio (%) of Thailand in 1987?
Ensure brevity in your answer.  6.77. What is the difference between the Gross enrolment ratio (%) in Myanmar in 1984 and the Gross enrolment ratio (%) in Thailand in 1987?
Your answer should be very brief. -3.23. What is the difference between the Gross enrolment ratio (%) of Low income in 1985 and the Gross enrolment ratio (%) of Angola in 1986?
Your answer should be very brief. -19.57. What is the difference between the Gross enrolment ratio (%) in Low income in 1985 and the Gross enrolment ratio (%) in Myanmar in 1986?
Provide a succinct answer. -23.08. What is the difference between the Gross enrolment ratio (%) of Low income in 1985 and the Gross enrolment ratio (%) of Thailand in 1986?
Ensure brevity in your answer.  -26.85. What is the difference between the Gross enrolment ratio (%) in Angola in 1985 and the Gross enrolment ratio (%) in Myanmar in 1986?
Give a very brief answer. -10.03. What is the difference between the Gross enrolment ratio (%) of Angola in 1985 and the Gross enrolment ratio (%) of Thailand in 1986?
Offer a very short reply. -13.8. What is the difference between the Gross enrolment ratio (%) in Myanmar in 1985 and the Gross enrolment ratio (%) in Thailand in 1986?
Make the answer very short. -4.24. What is the difference between the Gross enrolment ratio (%) in Low income in 1985 and the Gross enrolment ratio (%) in Angola in 1987?
Offer a terse response. -20.1. What is the difference between the Gross enrolment ratio (%) of Low income in 1985 and the Gross enrolment ratio (%) of Myanmar in 1987?
Keep it short and to the point. -27.28. What is the difference between the Gross enrolment ratio (%) in Low income in 1985 and the Gross enrolment ratio (%) in Thailand in 1987?
Your answer should be compact. -27.94. What is the difference between the Gross enrolment ratio (%) in Angola in 1985 and the Gross enrolment ratio (%) in Myanmar in 1987?
Offer a terse response. -14.23. What is the difference between the Gross enrolment ratio (%) in Angola in 1985 and the Gross enrolment ratio (%) in Thailand in 1987?
Offer a terse response. -14.9. What is the difference between the Gross enrolment ratio (%) in Myanmar in 1985 and the Gross enrolment ratio (%) in Thailand in 1987?
Provide a short and direct response. -5.34. What is the difference between the Gross enrolment ratio (%) of Low income in 1986 and the Gross enrolment ratio (%) of Angola in 1987?
Your response must be concise. -20.58. What is the difference between the Gross enrolment ratio (%) of Low income in 1986 and the Gross enrolment ratio (%) of Myanmar in 1987?
Offer a very short reply. -27.75. What is the difference between the Gross enrolment ratio (%) of Low income in 1986 and the Gross enrolment ratio (%) of Thailand in 1987?
Provide a succinct answer. -28.42. What is the difference between the Gross enrolment ratio (%) in Angola in 1986 and the Gross enrolment ratio (%) in Myanmar in 1987?
Offer a very short reply. -7.7. What is the difference between the Gross enrolment ratio (%) of Angola in 1986 and the Gross enrolment ratio (%) of Thailand in 1987?
Your answer should be very brief. -8.37. What is the difference between the Gross enrolment ratio (%) of Myanmar in 1986 and the Gross enrolment ratio (%) of Thailand in 1987?
Provide a short and direct response. -4.87. What is the average Gross enrolment ratio (%) of Low income per year?
Offer a very short reply. 69.87. What is the average Gross enrolment ratio (%) in Angola per year?
Offer a terse response. 115.26. What is the average Gross enrolment ratio (%) in Myanmar per year?
Ensure brevity in your answer.  91.88. What is the average Gross enrolment ratio (%) of Thailand per year?
Ensure brevity in your answer.  96.84. In the year 1980, what is the difference between the Gross enrolment ratio (%) of Low income and Gross enrolment ratio (%) of Angola?
Offer a terse response. -93.23. In the year 1980, what is the difference between the Gross enrolment ratio (%) in Low income and Gross enrolment ratio (%) in Myanmar?
Make the answer very short. -16.77. In the year 1980, what is the difference between the Gross enrolment ratio (%) of Low income and Gross enrolment ratio (%) of Thailand?
Offer a terse response. -26.58. In the year 1980, what is the difference between the Gross enrolment ratio (%) in Angola and Gross enrolment ratio (%) in Myanmar?
Your answer should be compact. 76.46. In the year 1980, what is the difference between the Gross enrolment ratio (%) in Angola and Gross enrolment ratio (%) in Thailand?
Offer a very short reply. 66.65. In the year 1980, what is the difference between the Gross enrolment ratio (%) of Myanmar and Gross enrolment ratio (%) of Thailand?
Your response must be concise. -9.81. In the year 1981, what is the difference between the Gross enrolment ratio (%) of Low income and Gross enrolment ratio (%) of Angola?
Your response must be concise. -71.53. In the year 1981, what is the difference between the Gross enrolment ratio (%) in Low income and Gross enrolment ratio (%) in Myanmar?
Ensure brevity in your answer.  -17.03. In the year 1981, what is the difference between the Gross enrolment ratio (%) of Low income and Gross enrolment ratio (%) of Thailand?
Your response must be concise. -25.64. In the year 1981, what is the difference between the Gross enrolment ratio (%) in Angola and Gross enrolment ratio (%) in Myanmar?
Your response must be concise. 54.5. In the year 1981, what is the difference between the Gross enrolment ratio (%) of Angola and Gross enrolment ratio (%) of Thailand?
Your response must be concise. 45.89. In the year 1981, what is the difference between the Gross enrolment ratio (%) of Myanmar and Gross enrolment ratio (%) of Thailand?
Your response must be concise. -8.61. In the year 1982, what is the difference between the Gross enrolment ratio (%) in Low income and Gross enrolment ratio (%) in Angola?
Your answer should be very brief. -61.67. In the year 1982, what is the difference between the Gross enrolment ratio (%) in Low income and Gross enrolment ratio (%) in Myanmar?
Offer a terse response. -21.21. In the year 1982, what is the difference between the Gross enrolment ratio (%) of Low income and Gross enrolment ratio (%) of Thailand?
Ensure brevity in your answer.  -26.76. In the year 1982, what is the difference between the Gross enrolment ratio (%) of Angola and Gross enrolment ratio (%) of Myanmar?
Ensure brevity in your answer.  40.46. In the year 1982, what is the difference between the Gross enrolment ratio (%) of Angola and Gross enrolment ratio (%) of Thailand?
Provide a short and direct response. 34.91. In the year 1982, what is the difference between the Gross enrolment ratio (%) of Myanmar and Gross enrolment ratio (%) of Thailand?
Provide a succinct answer. -5.55. In the year 1983, what is the difference between the Gross enrolment ratio (%) in Low income and Gross enrolment ratio (%) in Angola?
Offer a very short reply. -47.8. In the year 1983, what is the difference between the Gross enrolment ratio (%) of Low income and Gross enrolment ratio (%) of Myanmar?
Ensure brevity in your answer.  -21.93. In the year 1983, what is the difference between the Gross enrolment ratio (%) of Low income and Gross enrolment ratio (%) of Thailand?
Your response must be concise. -26.06. In the year 1983, what is the difference between the Gross enrolment ratio (%) in Angola and Gross enrolment ratio (%) in Myanmar?
Your answer should be very brief. 25.87. In the year 1983, what is the difference between the Gross enrolment ratio (%) in Angola and Gross enrolment ratio (%) in Thailand?
Offer a terse response. 21.74. In the year 1983, what is the difference between the Gross enrolment ratio (%) in Myanmar and Gross enrolment ratio (%) in Thailand?
Offer a terse response. -4.13. In the year 1984, what is the difference between the Gross enrolment ratio (%) of Low income and Gross enrolment ratio (%) of Angola?
Your response must be concise. -32.76. In the year 1984, what is the difference between the Gross enrolment ratio (%) in Low income and Gross enrolment ratio (%) in Myanmar?
Keep it short and to the point. -22.75. In the year 1984, what is the difference between the Gross enrolment ratio (%) of Low income and Gross enrolment ratio (%) of Thailand?
Keep it short and to the point. -25.29. In the year 1984, what is the difference between the Gross enrolment ratio (%) in Angola and Gross enrolment ratio (%) in Myanmar?
Your response must be concise. 10.01. In the year 1984, what is the difference between the Gross enrolment ratio (%) of Angola and Gross enrolment ratio (%) of Thailand?
Give a very brief answer. 7.47. In the year 1984, what is the difference between the Gross enrolment ratio (%) in Myanmar and Gross enrolment ratio (%) in Thailand?
Your answer should be compact. -2.54. In the year 1985, what is the difference between the Gross enrolment ratio (%) in Low income and Gross enrolment ratio (%) in Angola?
Offer a very short reply. -13.05. In the year 1985, what is the difference between the Gross enrolment ratio (%) in Low income and Gross enrolment ratio (%) in Myanmar?
Provide a succinct answer. -22.61. In the year 1985, what is the difference between the Gross enrolment ratio (%) of Low income and Gross enrolment ratio (%) of Thailand?
Give a very brief answer. -27.2. In the year 1985, what is the difference between the Gross enrolment ratio (%) of Angola and Gross enrolment ratio (%) of Myanmar?
Make the answer very short. -9.56. In the year 1985, what is the difference between the Gross enrolment ratio (%) of Angola and Gross enrolment ratio (%) of Thailand?
Provide a short and direct response. -14.15. In the year 1985, what is the difference between the Gross enrolment ratio (%) in Myanmar and Gross enrolment ratio (%) in Thailand?
Make the answer very short. -4.59. In the year 1986, what is the difference between the Gross enrolment ratio (%) in Low income and Gross enrolment ratio (%) in Angola?
Keep it short and to the point. -20.05. In the year 1986, what is the difference between the Gross enrolment ratio (%) in Low income and Gross enrolment ratio (%) in Myanmar?
Your answer should be very brief. -23.55. In the year 1986, what is the difference between the Gross enrolment ratio (%) of Low income and Gross enrolment ratio (%) of Thailand?
Ensure brevity in your answer.  -27.32. In the year 1986, what is the difference between the Gross enrolment ratio (%) in Angola and Gross enrolment ratio (%) in Myanmar?
Provide a short and direct response. -3.5. In the year 1986, what is the difference between the Gross enrolment ratio (%) of Angola and Gross enrolment ratio (%) of Thailand?
Ensure brevity in your answer.  -7.27. In the year 1986, what is the difference between the Gross enrolment ratio (%) in Myanmar and Gross enrolment ratio (%) in Thailand?
Offer a terse response. -3.77. In the year 1987, what is the difference between the Gross enrolment ratio (%) of Low income and Gross enrolment ratio (%) of Angola?
Make the answer very short. -23.03. In the year 1987, what is the difference between the Gross enrolment ratio (%) in Low income and Gross enrolment ratio (%) in Myanmar?
Keep it short and to the point. -30.2. In the year 1987, what is the difference between the Gross enrolment ratio (%) of Low income and Gross enrolment ratio (%) of Thailand?
Provide a succinct answer. -30.87. In the year 1987, what is the difference between the Gross enrolment ratio (%) in Angola and Gross enrolment ratio (%) in Myanmar?
Ensure brevity in your answer.  -7.17. In the year 1987, what is the difference between the Gross enrolment ratio (%) in Angola and Gross enrolment ratio (%) in Thailand?
Offer a very short reply. -7.84. In the year 1987, what is the difference between the Gross enrolment ratio (%) of Myanmar and Gross enrolment ratio (%) of Thailand?
Offer a terse response. -0.67. What is the ratio of the Gross enrolment ratio (%) of Low income in 1980 to that in 1981?
Offer a terse response. 0.97. What is the ratio of the Gross enrolment ratio (%) of Angola in 1980 to that in 1981?
Your response must be concise. 1.13. What is the ratio of the Gross enrolment ratio (%) of Myanmar in 1980 to that in 1981?
Offer a very short reply. 0.97. What is the ratio of the Gross enrolment ratio (%) of Thailand in 1980 to that in 1981?
Your answer should be compact. 0.98. What is the ratio of the Gross enrolment ratio (%) of Low income in 1980 to that in 1982?
Provide a short and direct response. 0.97. What is the ratio of the Gross enrolment ratio (%) in Angola in 1980 to that in 1982?
Give a very brief answer. 1.22. What is the ratio of the Gross enrolment ratio (%) of Myanmar in 1980 to that in 1982?
Make the answer very short. 0.93. What is the ratio of the Gross enrolment ratio (%) of Thailand in 1980 to that in 1982?
Your answer should be compact. 0.98. What is the ratio of the Gross enrolment ratio (%) of Low income in 1980 to that in 1983?
Make the answer very short. 0.97. What is the ratio of the Gross enrolment ratio (%) in Angola in 1980 to that in 1983?
Ensure brevity in your answer.  1.36. What is the ratio of the Gross enrolment ratio (%) in Myanmar in 1980 to that in 1983?
Offer a terse response. 0.92. What is the ratio of the Gross enrolment ratio (%) in Thailand in 1980 to that in 1983?
Offer a very short reply. 0.98. What is the ratio of the Gross enrolment ratio (%) in Low income in 1980 to that in 1984?
Make the answer very short. 0.98. What is the ratio of the Gross enrolment ratio (%) of Angola in 1980 to that in 1984?
Make the answer very short. 1.57. What is the ratio of the Gross enrolment ratio (%) of Myanmar in 1980 to that in 1984?
Offer a very short reply. 0.92. What is the ratio of the Gross enrolment ratio (%) in Thailand in 1980 to that in 1984?
Offer a terse response. 1. What is the ratio of the Gross enrolment ratio (%) of Angola in 1980 to that in 1985?
Keep it short and to the point. 1.98. What is the ratio of the Gross enrolment ratio (%) of Myanmar in 1980 to that in 1985?
Provide a succinct answer. 0.94. What is the ratio of the Gross enrolment ratio (%) in Thailand in 1980 to that in 1985?
Your answer should be compact. 1. What is the ratio of the Gross enrolment ratio (%) of Low income in 1980 to that in 1986?
Offer a very short reply. 1.01. What is the ratio of the Gross enrolment ratio (%) of Angola in 1980 to that in 1986?
Keep it short and to the point. 1.83. What is the ratio of the Gross enrolment ratio (%) of Myanmar in 1980 to that in 1986?
Provide a short and direct response. 0.94. What is the ratio of the Gross enrolment ratio (%) in Low income in 1980 to that in 1987?
Provide a short and direct response. 1.05. What is the ratio of the Gross enrolment ratio (%) in Angola in 1980 to that in 1987?
Provide a short and direct response. 1.82. What is the ratio of the Gross enrolment ratio (%) in Myanmar in 1980 to that in 1987?
Give a very brief answer. 0.89. What is the ratio of the Gross enrolment ratio (%) of Thailand in 1980 to that in 1987?
Offer a very short reply. 0.99. What is the ratio of the Gross enrolment ratio (%) of Angola in 1981 to that in 1982?
Keep it short and to the point. 1.08. What is the ratio of the Gross enrolment ratio (%) in Myanmar in 1981 to that in 1982?
Give a very brief answer. 0.96. What is the ratio of the Gross enrolment ratio (%) in Thailand in 1981 to that in 1982?
Give a very brief answer. 0.99. What is the ratio of the Gross enrolment ratio (%) in Low income in 1981 to that in 1983?
Provide a succinct answer. 1. What is the ratio of the Gross enrolment ratio (%) of Angola in 1981 to that in 1983?
Offer a very short reply. 1.2. What is the ratio of the Gross enrolment ratio (%) in Myanmar in 1981 to that in 1983?
Your answer should be very brief. 0.95. What is the ratio of the Gross enrolment ratio (%) in Thailand in 1981 to that in 1983?
Provide a succinct answer. 1. What is the ratio of the Gross enrolment ratio (%) of Low income in 1981 to that in 1984?
Ensure brevity in your answer.  1.01. What is the ratio of the Gross enrolment ratio (%) in Angola in 1981 to that in 1984?
Keep it short and to the point. 1.38. What is the ratio of the Gross enrolment ratio (%) of Myanmar in 1981 to that in 1984?
Give a very brief answer. 0.95. What is the ratio of the Gross enrolment ratio (%) in Thailand in 1981 to that in 1984?
Your response must be concise. 1.01. What is the ratio of the Gross enrolment ratio (%) of Low income in 1981 to that in 1985?
Provide a short and direct response. 1.04. What is the ratio of the Gross enrolment ratio (%) of Angola in 1981 to that in 1985?
Keep it short and to the point. 1.75. What is the ratio of the Gross enrolment ratio (%) of Myanmar in 1981 to that in 1985?
Offer a very short reply. 0.97. What is the ratio of the Gross enrolment ratio (%) in Thailand in 1981 to that in 1985?
Make the answer very short. 1.01. What is the ratio of the Gross enrolment ratio (%) of Low income in 1981 to that in 1986?
Provide a succinct answer. 1.05. What is the ratio of the Gross enrolment ratio (%) of Angola in 1981 to that in 1986?
Ensure brevity in your answer.  1.62. What is the ratio of the Gross enrolment ratio (%) in Myanmar in 1981 to that in 1986?
Your answer should be very brief. 0.96. What is the ratio of the Gross enrolment ratio (%) in Thailand in 1981 to that in 1986?
Make the answer very short. 1.02. What is the ratio of the Gross enrolment ratio (%) of Low income in 1981 to that in 1987?
Give a very brief answer. 1.09. What is the ratio of the Gross enrolment ratio (%) of Angola in 1981 to that in 1987?
Your answer should be compact. 1.61. What is the ratio of the Gross enrolment ratio (%) of Myanmar in 1981 to that in 1987?
Offer a terse response. 0.92. What is the ratio of the Gross enrolment ratio (%) in Low income in 1982 to that in 1983?
Provide a succinct answer. 1. What is the ratio of the Gross enrolment ratio (%) in Angola in 1982 to that in 1983?
Your answer should be very brief. 1.11. What is the ratio of the Gross enrolment ratio (%) of Myanmar in 1982 to that in 1983?
Provide a short and direct response. 0.99. What is the ratio of the Gross enrolment ratio (%) in Angola in 1982 to that in 1984?
Offer a terse response. 1.28. What is the ratio of the Gross enrolment ratio (%) of Myanmar in 1982 to that in 1984?
Offer a very short reply. 0.99. What is the ratio of the Gross enrolment ratio (%) of Thailand in 1982 to that in 1984?
Ensure brevity in your answer.  1.02. What is the ratio of the Gross enrolment ratio (%) of Low income in 1982 to that in 1985?
Your response must be concise. 1.03. What is the ratio of the Gross enrolment ratio (%) in Angola in 1982 to that in 1985?
Your answer should be very brief. 1.62. What is the ratio of the Gross enrolment ratio (%) of Myanmar in 1982 to that in 1985?
Make the answer very short. 1.01. What is the ratio of the Gross enrolment ratio (%) in Thailand in 1982 to that in 1985?
Provide a succinct answer. 1.02. What is the ratio of the Gross enrolment ratio (%) in Low income in 1982 to that in 1986?
Ensure brevity in your answer.  1.04. What is the ratio of the Gross enrolment ratio (%) in Angola in 1982 to that in 1986?
Provide a short and direct response. 1.5. What is the ratio of the Gross enrolment ratio (%) in Thailand in 1982 to that in 1986?
Make the answer very short. 1.02. What is the ratio of the Gross enrolment ratio (%) in Low income in 1982 to that in 1987?
Your answer should be very brief. 1.08. What is the ratio of the Gross enrolment ratio (%) in Angola in 1982 to that in 1987?
Provide a short and direct response. 1.49. What is the ratio of the Gross enrolment ratio (%) of Myanmar in 1982 to that in 1987?
Keep it short and to the point. 0.96. What is the ratio of the Gross enrolment ratio (%) of Thailand in 1982 to that in 1987?
Your answer should be very brief. 1.01. What is the ratio of the Gross enrolment ratio (%) of Low income in 1983 to that in 1984?
Keep it short and to the point. 1.01. What is the ratio of the Gross enrolment ratio (%) of Angola in 1983 to that in 1984?
Offer a terse response. 1.15. What is the ratio of the Gross enrolment ratio (%) of Thailand in 1983 to that in 1984?
Ensure brevity in your answer.  1.01. What is the ratio of the Gross enrolment ratio (%) of Low income in 1983 to that in 1985?
Ensure brevity in your answer.  1.04. What is the ratio of the Gross enrolment ratio (%) of Angola in 1983 to that in 1985?
Your answer should be compact. 1.45. What is the ratio of the Gross enrolment ratio (%) of Myanmar in 1983 to that in 1985?
Your answer should be compact. 1.02. What is the ratio of the Gross enrolment ratio (%) of Thailand in 1983 to that in 1985?
Ensure brevity in your answer.  1.01. What is the ratio of the Gross enrolment ratio (%) in Low income in 1983 to that in 1986?
Your response must be concise. 1.04. What is the ratio of the Gross enrolment ratio (%) of Angola in 1983 to that in 1986?
Provide a succinct answer. 1.35. What is the ratio of the Gross enrolment ratio (%) of Myanmar in 1983 to that in 1986?
Provide a succinct answer. 1.01. What is the ratio of the Gross enrolment ratio (%) of Thailand in 1983 to that in 1986?
Offer a very short reply. 1.02. What is the ratio of the Gross enrolment ratio (%) in Low income in 1983 to that in 1987?
Provide a succinct answer. 1.08. What is the ratio of the Gross enrolment ratio (%) in Angola in 1983 to that in 1987?
Your response must be concise. 1.34. What is the ratio of the Gross enrolment ratio (%) in Myanmar in 1983 to that in 1987?
Offer a terse response. 0.97. What is the ratio of the Gross enrolment ratio (%) of Thailand in 1983 to that in 1987?
Make the answer very short. 1.01. What is the ratio of the Gross enrolment ratio (%) in Low income in 1984 to that in 1985?
Your answer should be very brief. 1.03. What is the ratio of the Gross enrolment ratio (%) in Angola in 1984 to that in 1985?
Keep it short and to the point. 1.26. What is the ratio of the Gross enrolment ratio (%) of Myanmar in 1984 to that in 1985?
Your answer should be very brief. 1.02. What is the ratio of the Gross enrolment ratio (%) in Thailand in 1984 to that in 1985?
Offer a terse response. 1. What is the ratio of the Gross enrolment ratio (%) of Low income in 1984 to that in 1986?
Your answer should be compact. 1.04. What is the ratio of the Gross enrolment ratio (%) in Angola in 1984 to that in 1986?
Provide a succinct answer. 1.17. What is the ratio of the Gross enrolment ratio (%) in Myanmar in 1984 to that in 1986?
Provide a short and direct response. 1.02. What is the ratio of the Gross enrolment ratio (%) in Low income in 1984 to that in 1987?
Provide a short and direct response. 1.07. What is the ratio of the Gross enrolment ratio (%) of Angola in 1984 to that in 1987?
Give a very brief answer. 1.16. What is the ratio of the Gross enrolment ratio (%) in Myanmar in 1984 to that in 1987?
Your answer should be compact. 0.97. What is the ratio of the Gross enrolment ratio (%) in Low income in 1985 to that in 1986?
Keep it short and to the point. 1.01. What is the ratio of the Gross enrolment ratio (%) of Angola in 1985 to that in 1986?
Your answer should be very brief. 0.93. What is the ratio of the Gross enrolment ratio (%) of Low income in 1985 to that in 1987?
Your response must be concise. 1.04. What is the ratio of the Gross enrolment ratio (%) in Angola in 1985 to that in 1987?
Your response must be concise. 0.92. What is the ratio of the Gross enrolment ratio (%) of Myanmar in 1985 to that in 1987?
Your response must be concise. 0.95. What is the ratio of the Gross enrolment ratio (%) of Low income in 1986 to that in 1987?
Offer a very short reply. 1.04. What is the ratio of the Gross enrolment ratio (%) of Myanmar in 1986 to that in 1987?
Your answer should be very brief. 0.96. What is the ratio of the Gross enrolment ratio (%) in Thailand in 1986 to that in 1987?
Provide a succinct answer. 0.99. What is the difference between the highest and the second highest Gross enrolment ratio (%) of Low income?
Your response must be concise. 0.21. What is the difference between the highest and the second highest Gross enrolment ratio (%) in Angola?
Offer a terse response. 19.3. What is the difference between the highest and the second highest Gross enrolment ratio (%) in Myanmar?
Your response must be concise. 2.57. What is the difference between the highest and the second highest Gross enrolment ratio (%) of Thailand?
Provide a short and direct response. 0.47. What is the difference between the highest and the lowest Gross enrolment ratio (%) of Low income?
Give a very brief answer. 5.64. What is the difference between the highest and the lowest Gross enrolment ratio (%) in Angola?
Give a very brief answer. 80.49. What is the difference between the highest and the lowest Gross enrolment ratio (%) of Myanmar?
Offer a very short reply. 10.19. What is the difference between the highest and the lowest Gross enrolment ratio (%) in Thailand?
Keep it short and to the point. 2.19. 